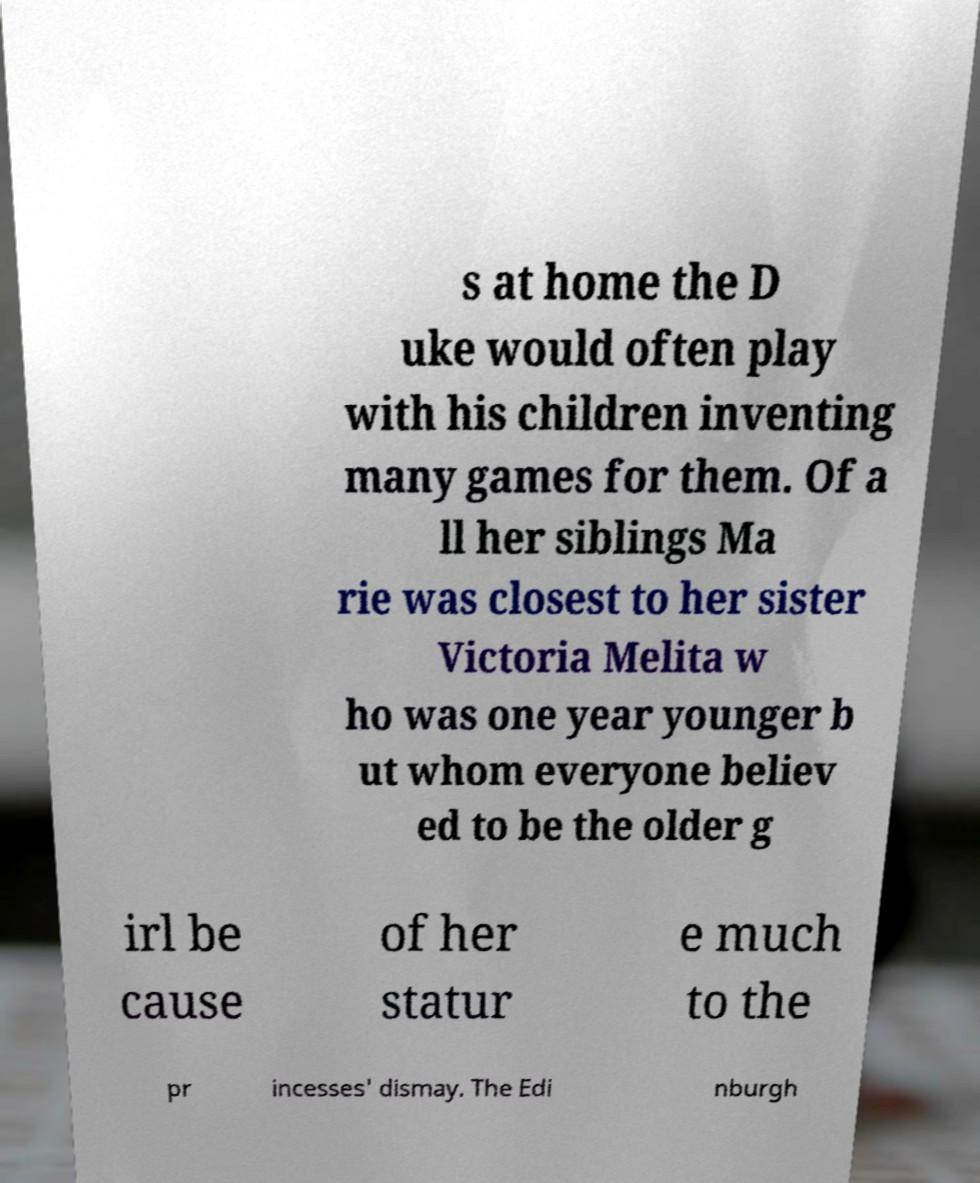Can you read and provide the text displayed in the image?This photo seems to have some interesting text. Can you extract and type it out for me? s at home the D uke would often play with his children inventing many games for them. Of a ll her siblings Ma rie was closest to her sister Victoria Melita w ho was one year younger b ut whom everyone believ ed to be the older g irl be cause of her statur e much to the pr incesses' dismay. The Edi nburgh 